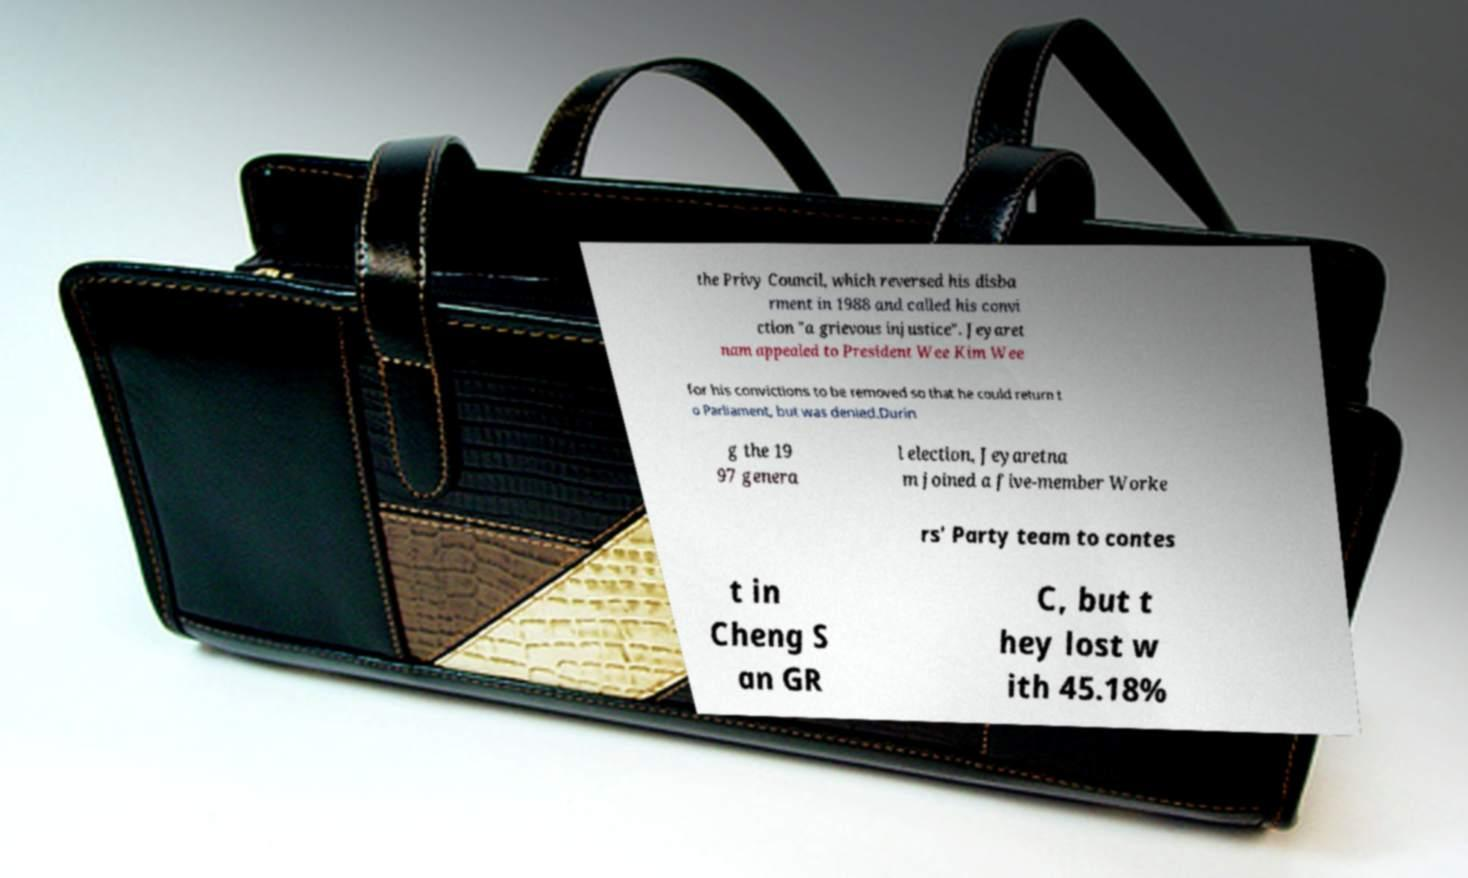Could you extract and type out the text from this image? the Privy Council, which reversed his disba rment in 1988 and called his convi ction "a grievous injustice". Jeyaret nam appealed to President Wee Kim Wee for his convictions to be removed so that he could return t o Parliament, but was denied.Durin g the 19 97 genera l election, Jeyaretna m joined a five-member Worke rs' Party team to contes t in Cheng S an GR C, but t hey lost w ith 45.18% 